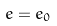Convert formula to latex. <formula><loc_0><loc_0><loc_500><loc_500>e = e _ { 0 }</formula> 